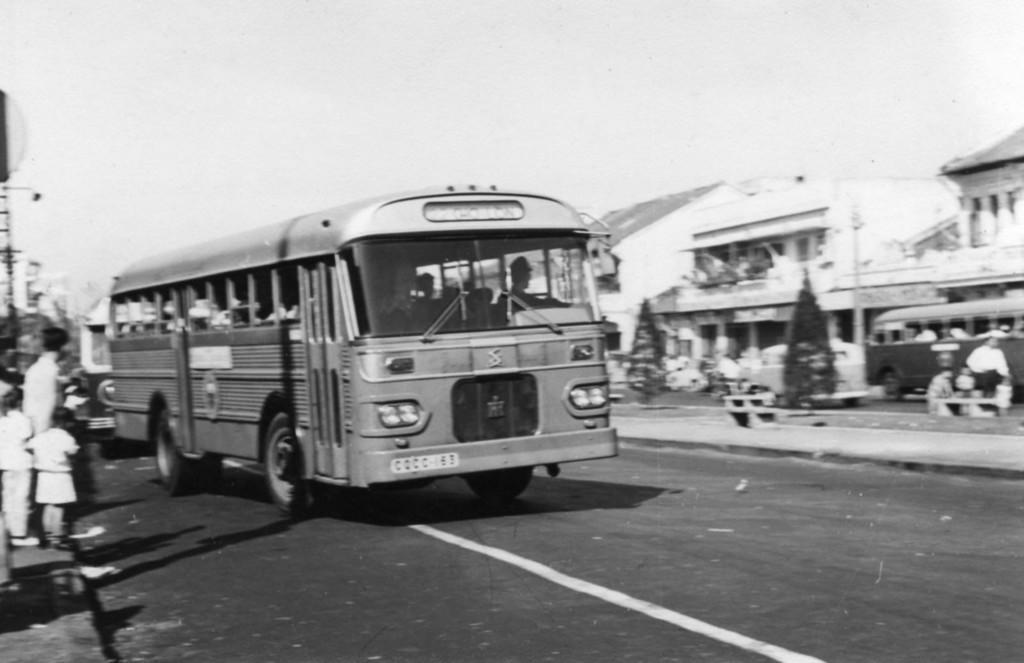Can you describe this image briefly? In this picture there are people on left side. There are buses in the foreground and right side. There is a road at the bottom, The sky is at the top. 